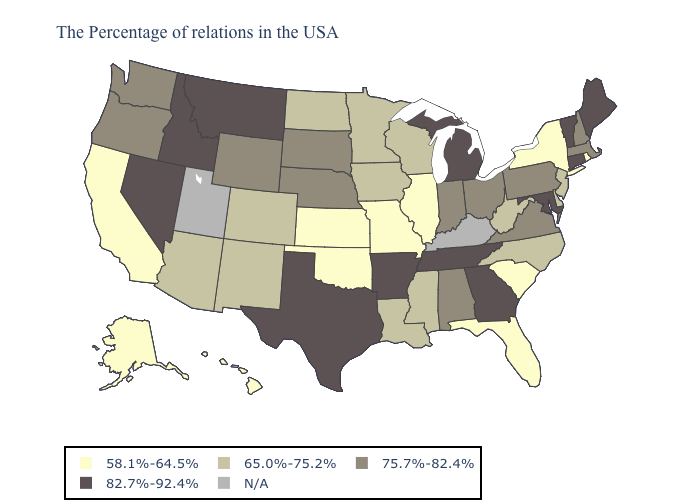Name the states that have a value in the range 82.7%-92.4%?
Answer briefly. Maine, Vermont, Connecticut, Maryland, Georgia, Michigan, Tennessee, Arkansas, Texas, Montana, Idaho, Nevada. Among the states that border Vermont , which have the highest value?
Concise answer only. Massachusetts, New Hampshire. Name the states that have a value in the range 58.1%-64.5%?
Concise answer only. Rhode Island, New York, South Carolina, Florida, Illinois, Missouri, Kansas, Oklahoma, California, Alaska, Hawaii. Does Kansas have the highest value in the MidWest?
Quick response, please. No. What is the value of North Dakota?
Give a very brief answer. 65.0%-75.2%. What is the value of New Mexico?
Give a very brief answer. 65.0%-75.2%. Name the states that have a value in the range 82.7%-92.4%?
Answer briefly. Maine, Vermont, Connecticut, Maryland, Georgia, Michigan, Tennessee, Arkansas, Texas, Montana, Idaho, Nevada. Does the map have missing data?
Short answer required. Yes. What is the highest value in the USA?
Concise answer only. 82.7%-92.4%. What is the value of Oklahoma?
Answer briefly. 58.1%-64.5%. What is the lowest value in the MidWest?
Short answer required. 58.1%-64.5%. Name the states that have a value in the range 65.0%-75.2%?
Short answer required. New Jersey, Delaware, North Carolina, West Virginia, Wisconsin, Mississippi, Louisiana, Minnesota, Iowa, North Dakota, Colorado, New Mexico, Arizona. What is the highest value in the USA?
Answer briefly. 82.7%-92.4%. Which states have the highest value in the USA?
Quick response, please. Maine, Vermont, Connecticut, Maryland, Georgia, Michigan, Tennessee, Arkansas, Texas, Montana, Idaho, Nevada. 